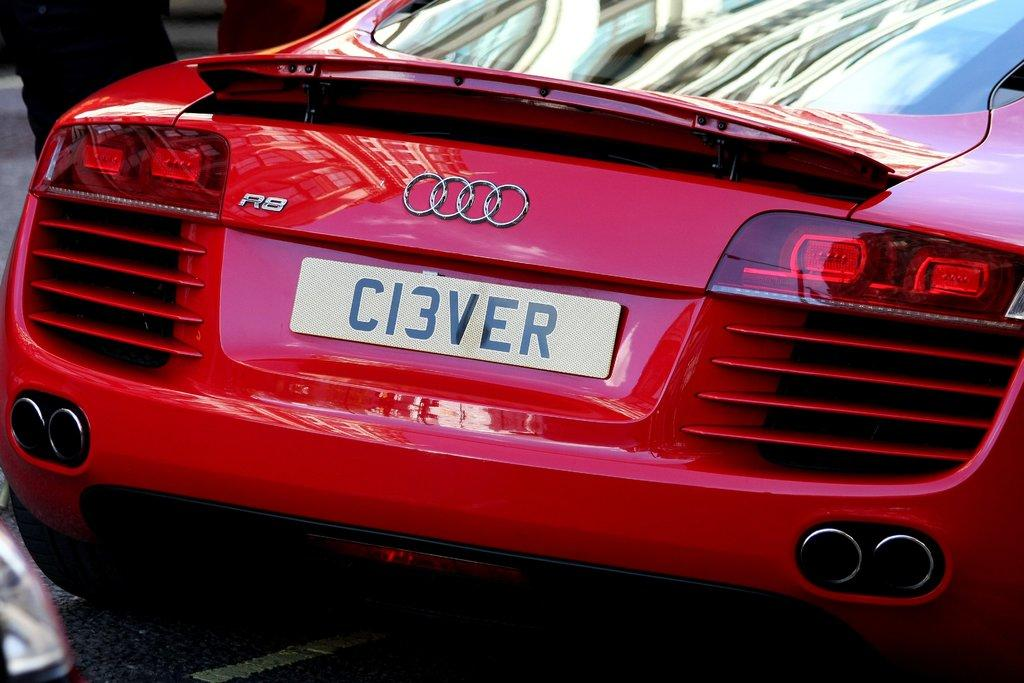What color is the car in the image? The car in the image is red. Where is the car located in the image? The car is on the road. What flavor of paint is used on the car in the image? The image does not provide information about the flavor of paint used on the car, as it only mentions the color of the car. 